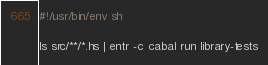<code> <loc_0><loc_0><loc_500><loc_500><_Bash_>#!/usr/bin/env sh

ls src/**/*.hs | entr -c cabal run library-tests
</code> 